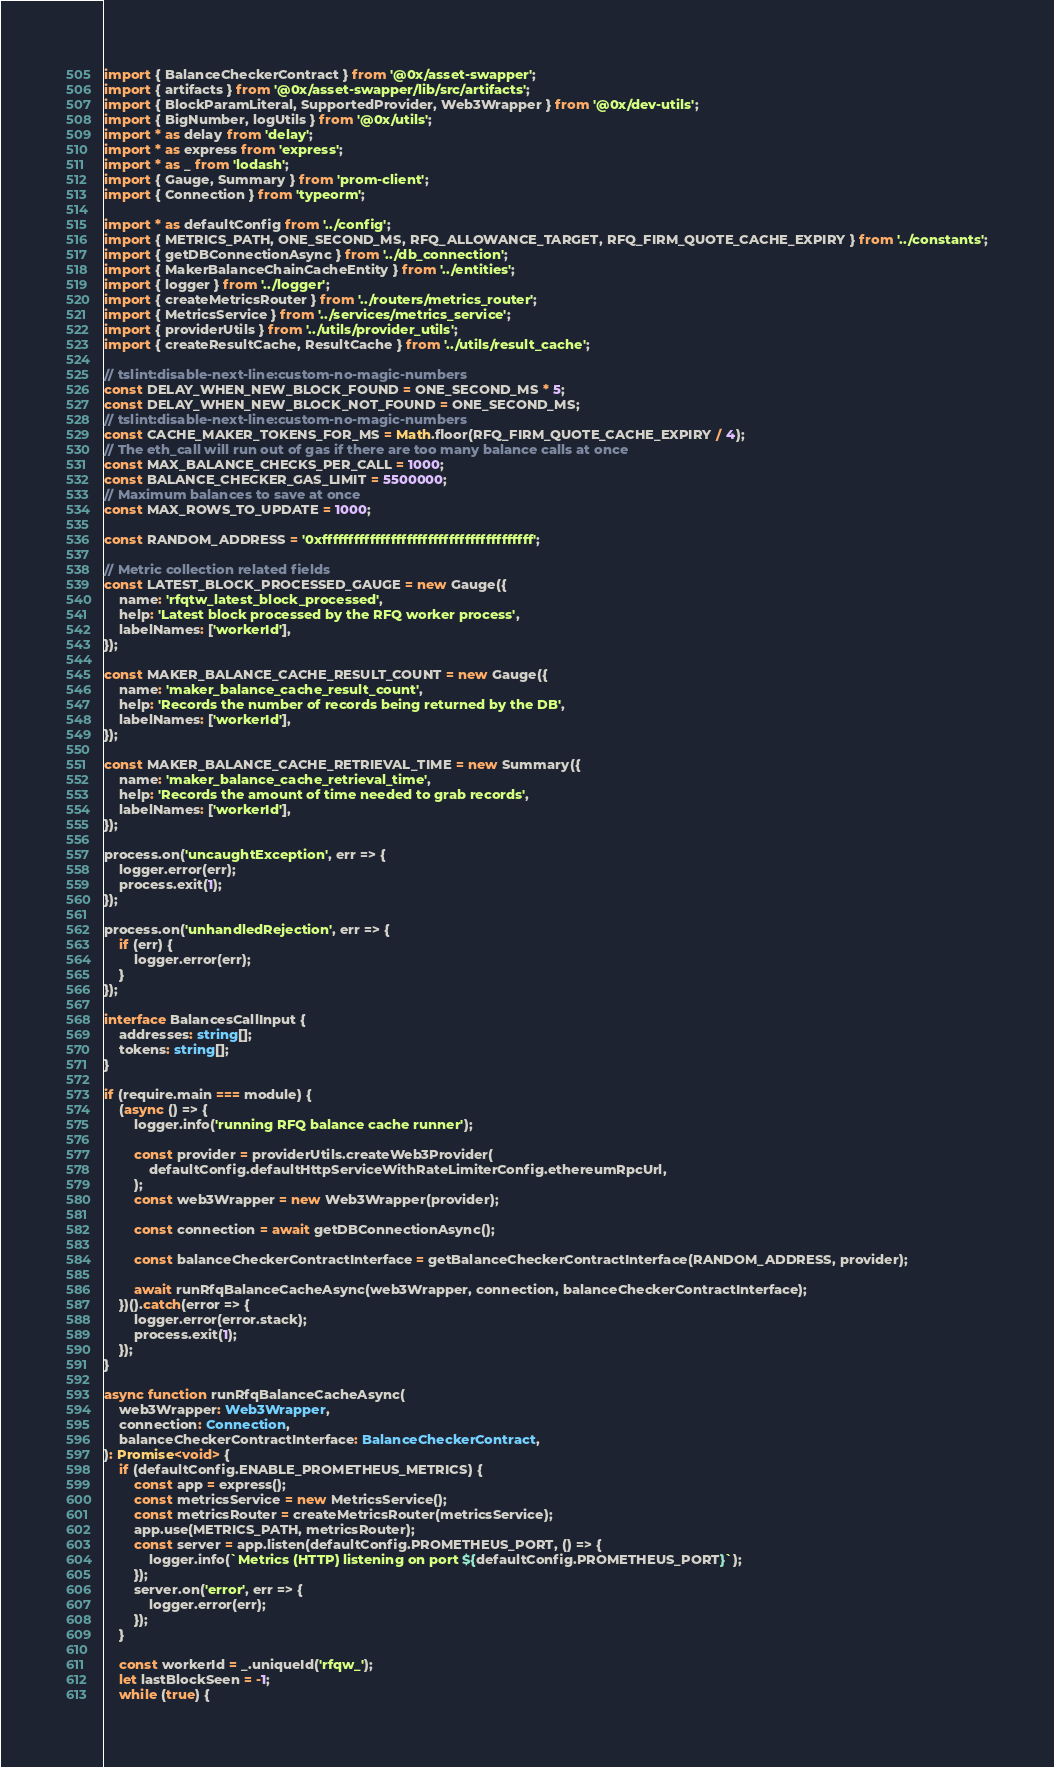<code> <loc_0><loc_0><loc_500><loc_500><_TypeScript_>import { BalanceCheckerContract } from '@0x/asset-swapper';
import { artifacts } from '@0x/asset-swapper/lib/src/artifacts';
import { BlockParamLiteral, SupportedProvider, Web3Wrapper } from '@0x/dev-utils';
import { BigNumber, logUtils } from '@0x/utils';
import * as delay from 'delay';
import * as express from 'express';
import * as _ from 'lodash';
import { Gauge, Summary } from 'prom-client';
import { Connection } from 'typeorm';

import * as defaultConfig from '../config';
import { METRICS_PATH, ONE_SECOND_MS, RFQ_ALLOWANCE_TARGET, RFQ_FIRM_QUOTE_CACHE_EXPIRY } from '../constants';
import { getDBConnectionAsync } from '../db_connection';
import { MakerBalanceChainCacheEntity } from '../entities';
import { logger } from '../logger';
import { createMetricsRouter } from '../routers/metrics_router';
import { MetricsService } from '../services/metrics_service';
import { providerUtils } from '../utils/provider_utils';
import { createResultCache, ResultCache } from '../utils/result_cache';

// tslint:disable-next-line:custom-no-magic-numbers
const DELAY_WHEN_NEW_BLOCK_FOUND = ONE_SECOND_MS * 5;
const DELAY_WHEN_NEW_BLOCK_NOT_FOUND = ONE_SECOND_MS;
// tslint:disable-next-line:custom-no-magic-numbers
const CACHE_MAKER_TOKENS_FOR_MS = Math.floor(RFQ_FIRM_QUOTE_CACHE_EXPIRY / 4);
// The eth_call will run out of gas if there are too many balance calls at once
const MAX_BALANCE_CHECKS_PER_CALL = 1000;
const BALANCE_CHECKER_GAS_LIMIT = 5500000;
// Maximum balances to save at once
const MAX_ROWS_TO_UPDATE = 1000;

const RANDOM_ADDRESS = '0xffffffffffffffffffffffffffffffffffffffff';

// Metric collection related fields
const LATEST_BLOCK_PROCESSED_GAUGE = new Gauge({
    name: 'rfqtw_latest_block_processed',
    help: 'Latest block processed by the RFQ worker process',
    labelNames: ['workerId'],
});

const MAKER_BALANCE_CACHE_RESULT_COUNT = new Gauge({
    name: 'maker_balance_cache_result_count',
    help: 'Records the number of records being returned by the DB',
    labelNames: ['workerId'],
});

const MAKER_BALANCE_CACHE_RETRIEVAL_TIME = new Summary({
    name: 'maker_balance_cache_retrieval_time',
    help: 'Records the amount of time needed to grab records',
    labelNames: ['workerId'],
});

process.on('uncaughtException', err => {
    logger.error(err);
    process.exit(1);
});

process.on('unhandledRejection', err => {
    if (err) {
        logger.error(err);
    }
});

interface BalancesCallInput {
    addresses: string[];
    tokens: string[];
}

if (require.main === module) {
    (async () => {
        logger.info('running RFQ balance cache runner');

        const provider = providerUtils.createWeb3Provider(
            defaultConfig.defaultHttpServiceWithRateLimiterConfig.ethereumRpcUrl,
        );
        const web3Wrapper = new Web3Wrapper(provider);

        const connection = await getDBConnectionAsync();

        const balanceCheckerContractInterface = getBalanceCheckerContractInterface(RANDOM_ADDRESS, provider);

        await runRfqBalanceCacheAsync(web3Wrapper, connection, balanceCheckerContractInterface);
    })().catch(error => {
        logger.error(error.stack);
        process.exit(1);
    });
}

async function runRfqBalanceCacheAsync(
    web3Wrapper: Web3Wrapper,
    connection: Connection,
    balanceCheckerContractInterface: BalanceCheckerContract,
): Promise<void> {
    if (defaultConfig.ENABLE_PROMETHEUS_METRICS) {
        const app = express();
        const metricsService = new MetricsService();
        const metricsRouter = createMetricsRouter(metricsService);
        app.use(METRICS_PATH, metricsRouter);
        const server = app.listen(defaultConfig.PROMETHEUS_PORT, () => {
            logger.info(`Metrics (HTTP) listening on port ${defaultConfig.PROMETHEUS_PORT}`);
        });
        server.on('error', err => {
            logger.error(err);
        });
    }

    const workerId = _.uniqueId('rfqw_');
    let lastBlockSeen = -1;
    while (true) {</code> 